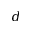<formula> <loc_0><loc_0><loc_500><loc_500>d</formula> 